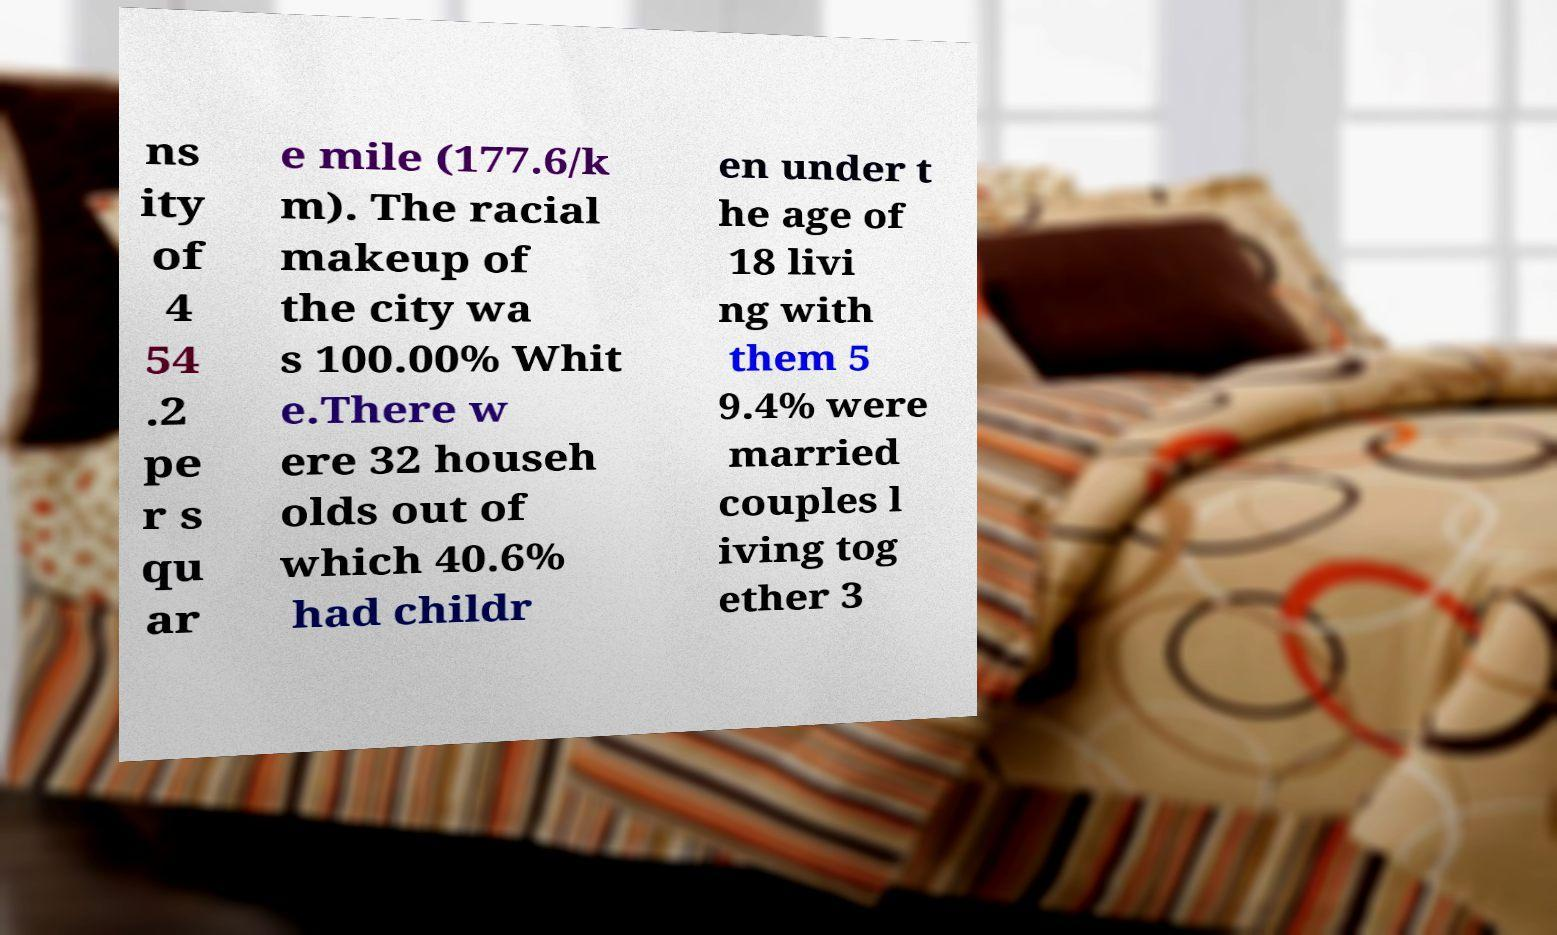Can you accurately transcribe the text from the provided image for me? ns ity of 4 54 .2 pe r s qu ar e mile (177.6/k m). The racial makeup of the city wa s 100.00% Whit e.There w ere 32 househ olds out of which 40.6% had childr en under t he age of 18 livi ng with them 5 9.4% were married couples l iving tog ether 3 